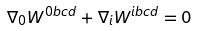<formula> <loc_0><loc_0><loc_500><loc_500>\nabla _ { 0 } W ^ { 0 b c d } + \nabla _ { i } W ^ { i b c d } = 0</formula> 